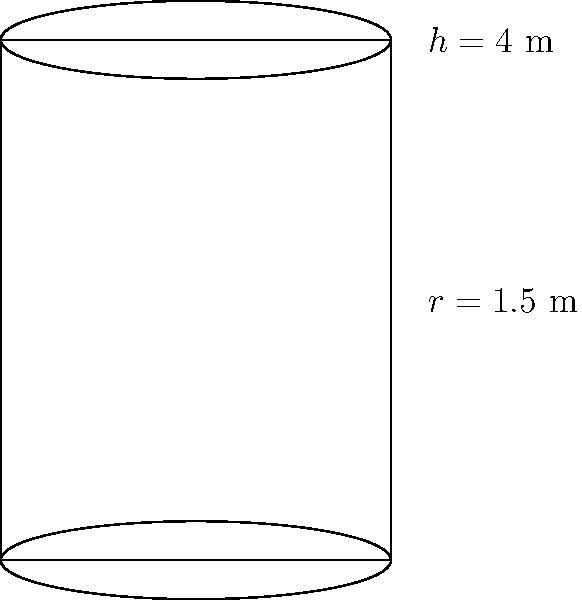As a record label CEO exploring the commercial potential of jazz fusion, you're organizing a performance featuring a custom cylindrical speaker. The speaker has a radius of 1.5 meters and a height of 4 meters. To estimate production costs, you need to calculate the total surface area of the speaker, including the top and bottom circular faces. What is the total surface area of the cylindrical speaker in square meters? To calculate the total surface area of a cylinder, we need to add the areas of three parts:
1. The lateral surface area (curved side)
2. The top circular face
3. The bottom circular face

Step 1: Calculate the lateral surface area
The formula for the lateral surface area is $2\pi rh$, where $r$ is the radius and $h$ is the height.
Lateral surface area $= 2\pi \cdot 1.5 \cdot 4 = 12\pi$ m²

Step 2: Calculate the area of one circular face
The formula for the area of a circle is $\pi r^2$
Area of one circular face $= \pi \cdot 1.5^2 = 2.25\pi$ m²

Step 3: Calculate the total surface area
Total surface area = Lateral surface area + 2 × Area of one circular face
$= 12\pi + 2(2.25\pi)$
$= 12\pi + 4.5\pi$
$= 16.5\pi$ m²

Step 4: Simplify the answer
$16.5\pi \approx 51.84$ m² (rounded to two decimal places)
Answer: 51.84 m² 